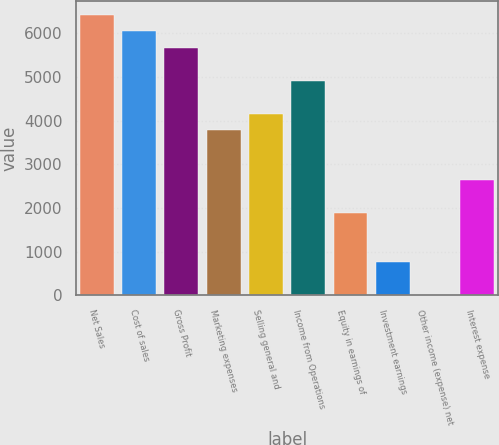Convert chart to OTSL. <chart><loc_0><loc_0><loc_500><loc_500><bar_chart><fcel>Net Sales<fcel>Cost of sales<fcel>Gross Profit<fcel>Marketing expenses<fcel>Selling general and<fcel>Income from Operations<fcel>Equity in earnings of<fcel>Investment earnings<fcel>Other income (expense) net<fcel>Interest expense<nl><fcel>6419.33<fcel>6041.74<fcel>5664.15<fcel>3776.2<fcel>4153.79<fcel>4908.97<fcel>1888.25<fcel>755.48<fcel>0.3<fcel>2643.43<nl></chart> 